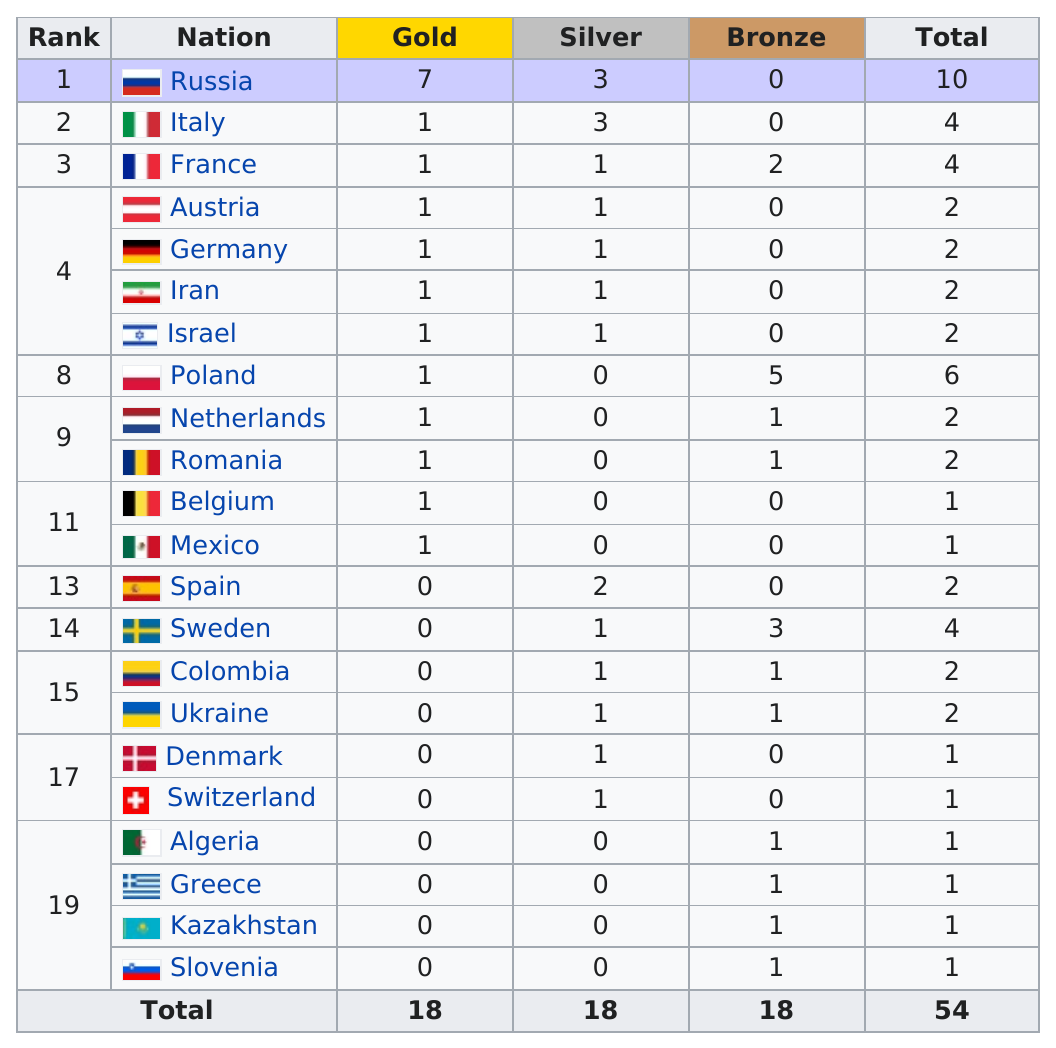Specify some key components in this picture. There are 12 countries that have ranks in the double digits. Russia is ranked first on the list. Russia had six more golds than Germany. Russia is the first-ranking nation in the world. Russia's total gold reserves are approximately 7. 